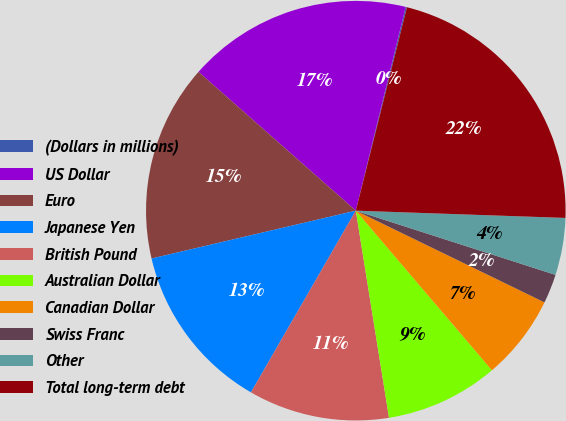Convert chart. <chart><loc_0><loc_0><loc_500><loc_500><pie_chart><fcel>(Dollars in millions)<fcel>US Dollar<fcel>Euro<fcel>Japanese Yen<fcel>British Pound<fcel>Australian Dollar<fcel>Canadian Dollar<fcel>Swiss Franc<fcel>Other<fcel>Total long-term debt<nl><fcel>0.1%<fcel>17.32%<fcel>15.17%<fcel>13.01%<fcel>10.86%<fcel>8.71%<fcel>6.56%<fcel>2.25%<fcel>4.4%<fcel>21.63%<nl></chart> 